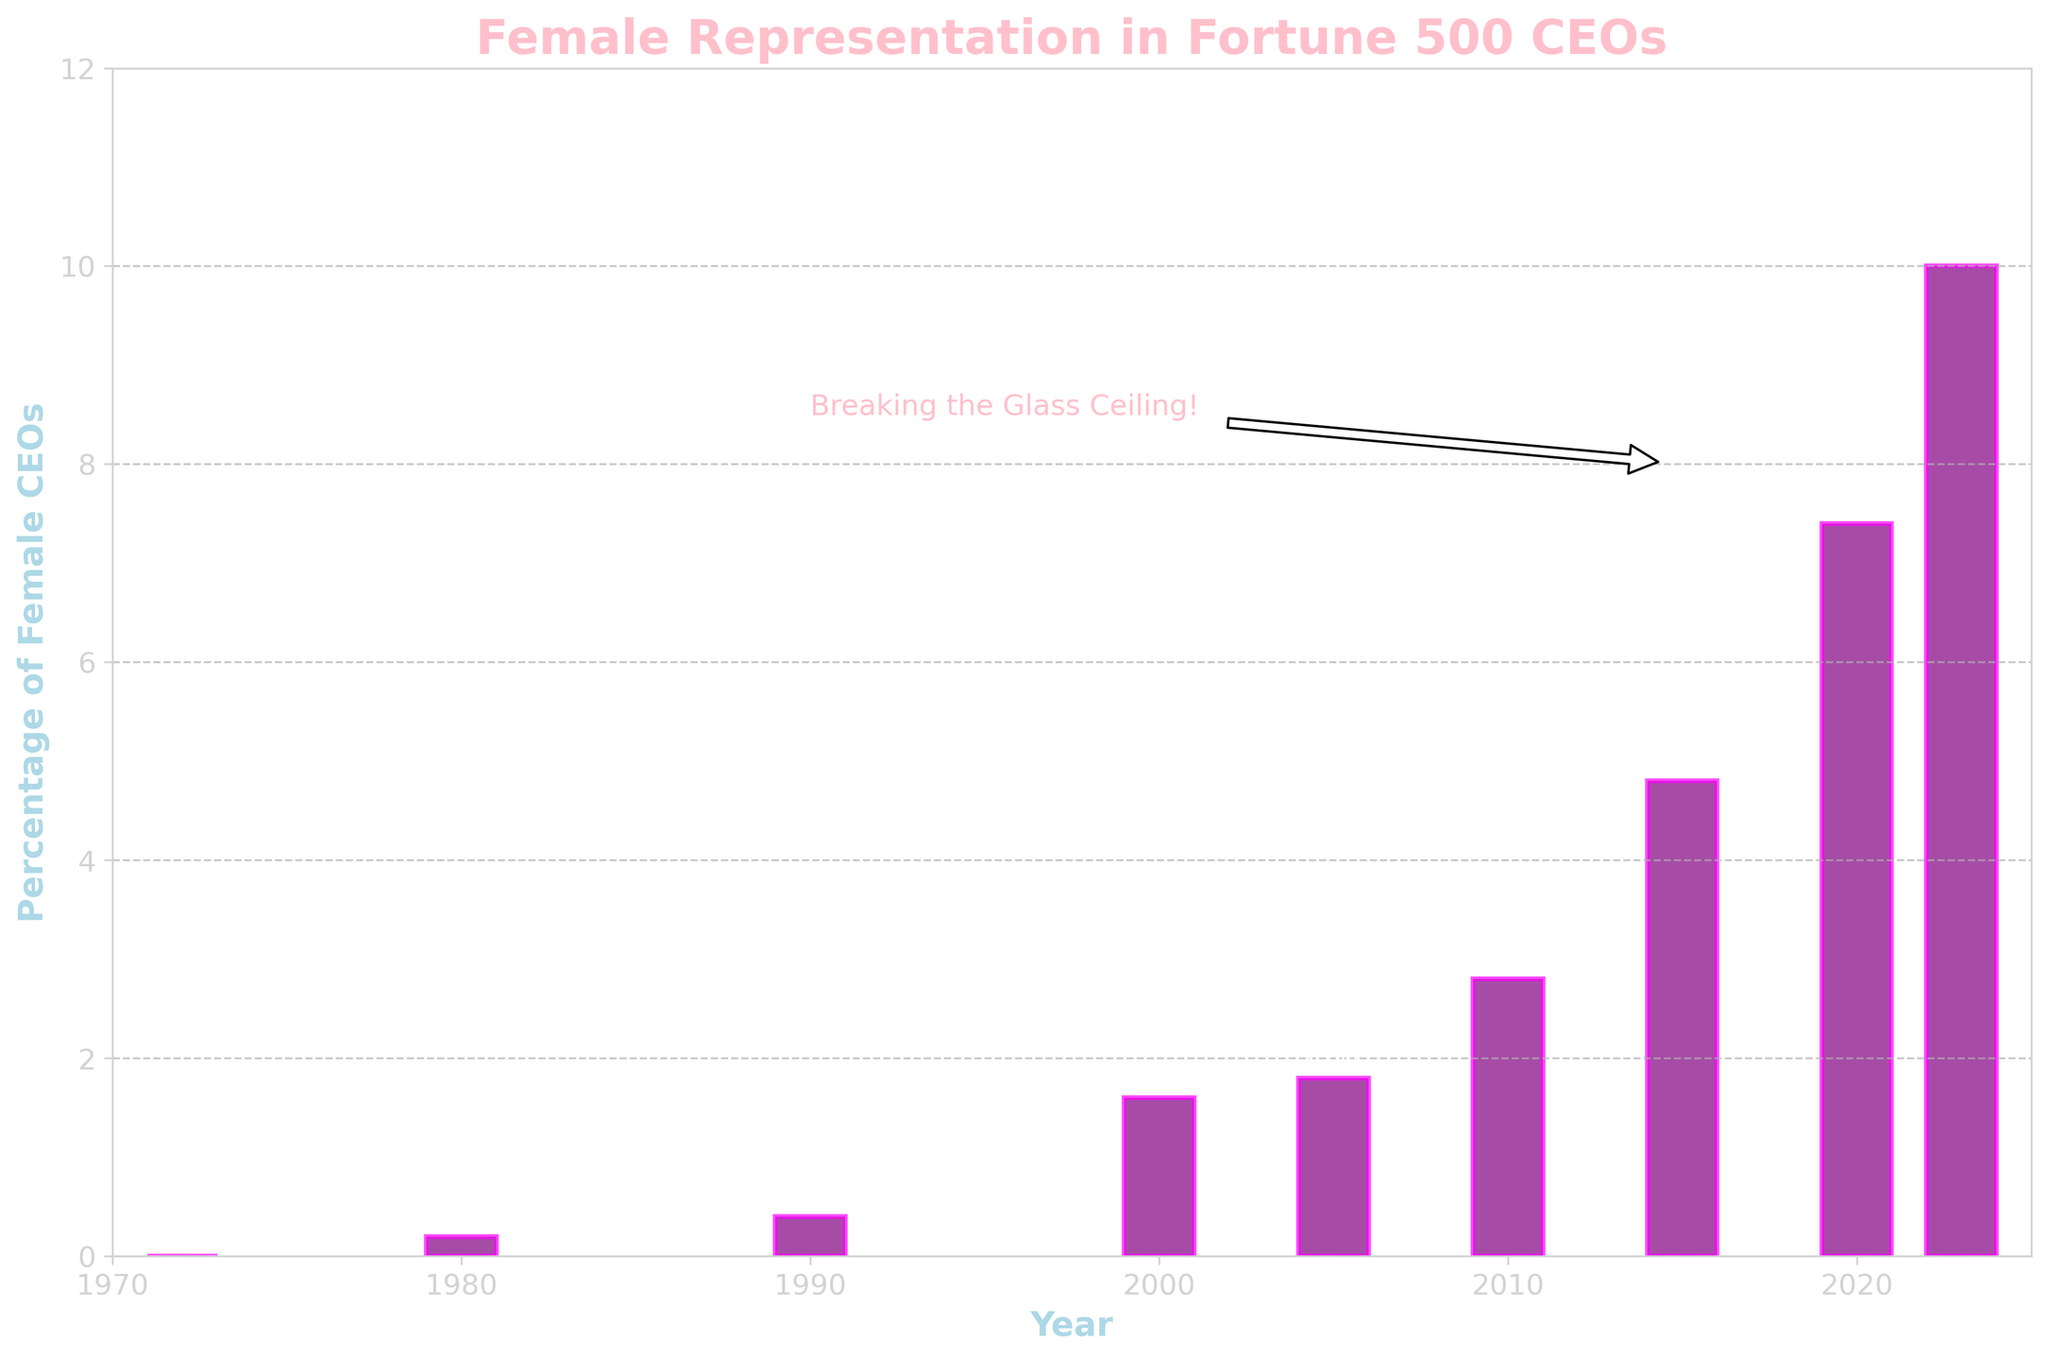What is the percentage increase in female CEOs from 1972 to 2023? The percentage of female CEOs in 1972 is 0.0%, and it increased to 10.0% in 2023. The increase can be calculated by subtracting the earlier percentage from the later percentage: 10.0% - 0.0% = 10.0%
Answer: 10.0% What is the median percentage of female CEOs over the years displayed? To find the median, list the percentages in order: 0.0%, 0.2%, 0.4%, 1.6%, 1.8%, 2.8%, 4.8%, 7.4%, 10.0%. With 9 data points, the median is the middle value in this list: 1.8%
Answer: 1.8% Between which consecutive years did the percentage of female CEOs increase the most? Calculate the differences between consecutive years: 1980-1972 (0.2%-0.0%=0.2%), 1990-1980 (0.4%-0.2%=0.2%), 2000-1990 (1.6%-0.4%=1.2%), 2005-2000 (1.8%-1.6%=0.2%), 2010-2005 (2.8%-1.8%=1.0%), 2015-2010 (4.8%-2.8%=2.0%), 2020-2015 (7.4%-4.8%=2.6%), 2023-2020 (10.0%-7.4%=2.6%). The largest increase is between 2015 and 2020, and between 2020 and 2023, both with an increase of 2.6%.
Answer: Between 2015 and 2020, and between 2020 and 2023 What is the average percentage of female CEOs in the year 2000 and 2020? First, sum the percentages for the years 2000 and 2020 (1.6% + 7.4% = 9.0%), then divide by the number of years (2): 9.0% / 2 = 4.5%
Answer: 4.5% Which year marked the first time the percentage of female CEOs reached or surpassed 2%? Identify the first bar with a height equal to or greater than 2%. In the year 2000, the percentage was 1.6%, and in 2005 it was 1.8%, but it reached 2.8% in 2010, marking the first year surpassing 2%.
Answer: 2010 How does the proportion of female CEOs in 2023 compare to that in 2000? In 2000, the percentage was 1.6%, and in 2023 it was 10.0%. The ratio is 10.0% / 1.6% = 6.25, meaning the proportion in 2023 is 6.25 times higher than in 2000.
Answer: 6.25 times higher 